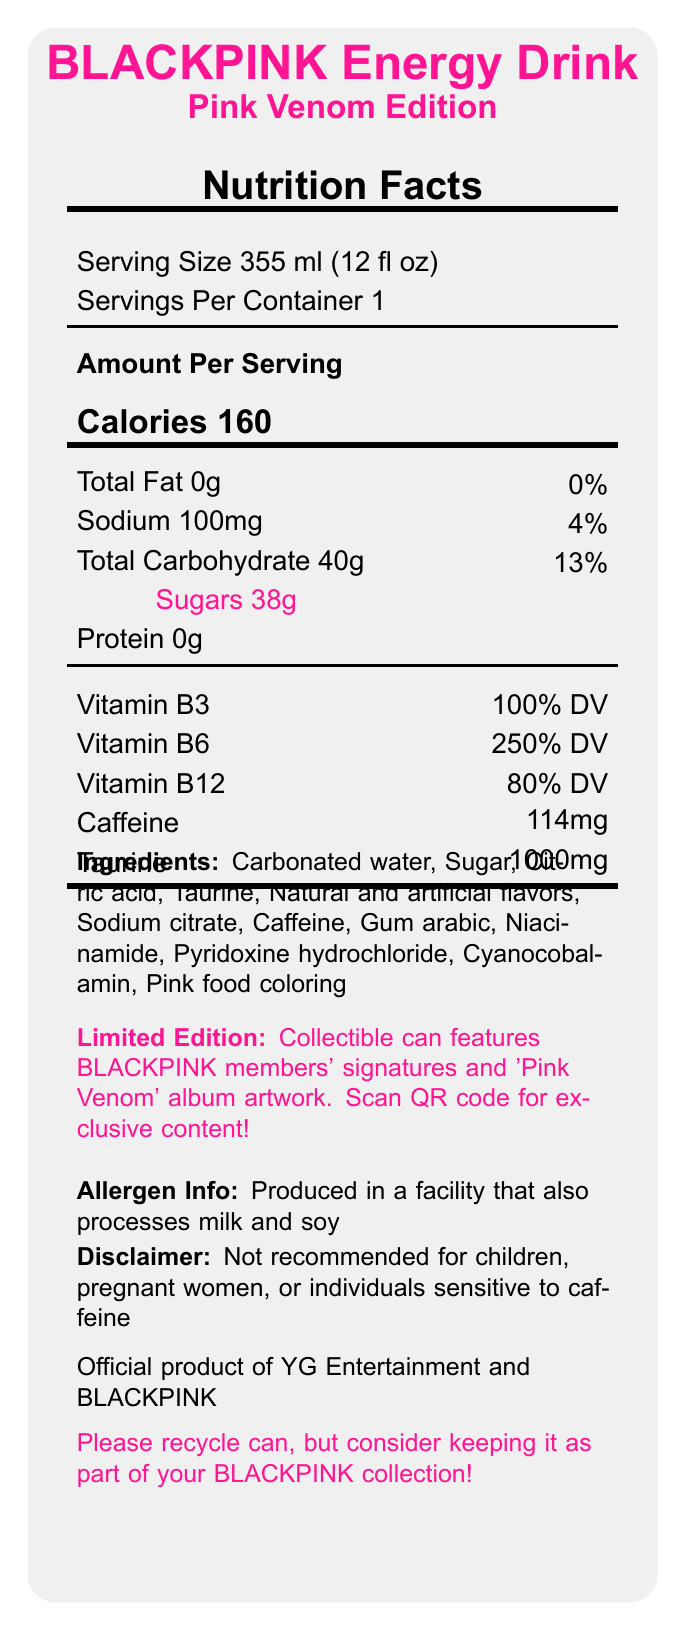what is the serving size of the BLACKPINK Energy Drink: Pink Venom Edition? The serving size is explicitly stated under "Serving Size 355 ml (12 fl oz)."
Answer: 355 ml (12 fl oz) how many calories are in one serving of this energy drink? The document specifies the number of calories as "Calories 160" under the "Amount Per Serving" section.
Answer: 160 what percentage of the daily value of Vitamin B6 does this drink provide? The percentage of daily value for Vitamin B6 is listed as "250% DV" in the vitamins and minerals section.
Answer: 250% list the ingredients of the BLACKPINK Energy Drink: Pink Venom Edition. The ingredients are listed under the “Ingredients” section in the document.
Answer: Carbonated water, Sugar, Citric acid, Taurine, Natural and artificial flavors, Sodium citrate, Caffeine, Gum arabic, Niacinamide, Pyridoxine hydrochloride, Cyanocobalamin, Pink food coloring how much sugar does the drink contain? The document indicates that the drink contains “Sugars 38g.”
Answer: 38g what is the amount of caffeine in the drink? The caffeine content is listed as "114mg" in the vitamins and minerals section.
Answer: 114mg how many servings are there per container? The document mentions there is "1" serving per container in the “Servings Per Container” section.
Answer: 1 is the BLACKPINK Energy Drink safe for pregnant women? The disclaimer section states that the drink is "not recommended for pregnant women."
Answer: No what is the total carbohydrate content in a serving of this energy drink? The document indicates that the total carbohydrate content is "Total Carbohydrate 40g."
Answer: 40g which vitamin is provided at 100% of the daily value in this drink? 
- A. Vitamin B3
- B. Vitamin B6
- C. Vitamin B12 
- D. Vitamin C The document specifies that the drink provides "Vitamin B3 100% DV."
Answer: A. Vitamin B3 what bonus comes with the purchase of this drink?
- I. Free concert ticket
- II. QR code for exclusive BLACKPINK content
- III. Limited edition poster
- IV. Meet and greet with BLACKPINK The additional info section states that each can includes a "QR code for exclusive BLACKPINK content."
Answer: II. QR code for exclusive BLACKPINK content does the can feature the signatures of BLACKPINK members? The additional info section states that the collectible can design "features BLACKPINK members' signatures."
Answer: Yes how much taurine does one serving of the BLACKPINK Energy Drink contain? The document lists the taurine content as "Taurine 1000mg."
Answer: 1000mg is there any mention of allergens in the product information? The allergen info section states the product is "produced in a facility that also processes milk and soy."
Answer: Yes can individuals sensitive to caffeine safely consume this drink? The disclaimer states that the drink is "not recommended for individuals sensitive to caffeine."
Answer: No summarize the main features of the BLACKPINK Energy Drink: Pink Venom Edition. This answer is a detailed description summarizing the key features and information provided in the document.
Answer: The BLACKPINK Energy Drink: Pink Venom Edition is a limited-edition energy drink featuring BLACKPINK's signatures and artwork. It has a serving size of 355 ml (12 fl oz) and contains 160 calories, 0g fat, 100mg sodium, 40g total carbohydrates, 38g sugars, and 0g protein. It also contains 114mg caffeine and 1000mg taurine. The drink provides significant daily values of Vitamin B3, B6, and B12. Each can includes a QR code for exclusive content, and collecting all four designs offers a chance to win VIP concert tickets. It is not recommended for children, pregnant women, or those sensitive to caffeine. The product encourages recycling and is an official item of YG Entertainment and BLACKPINK. how many collectible can designs are there to collect in this edition? The document mentions "collect all 4 member-specific can designs" for a chance to win VIP concert tickets, but it doesn't specify if these are the only designs available or if there are more.
Answer: Cannot be determined 